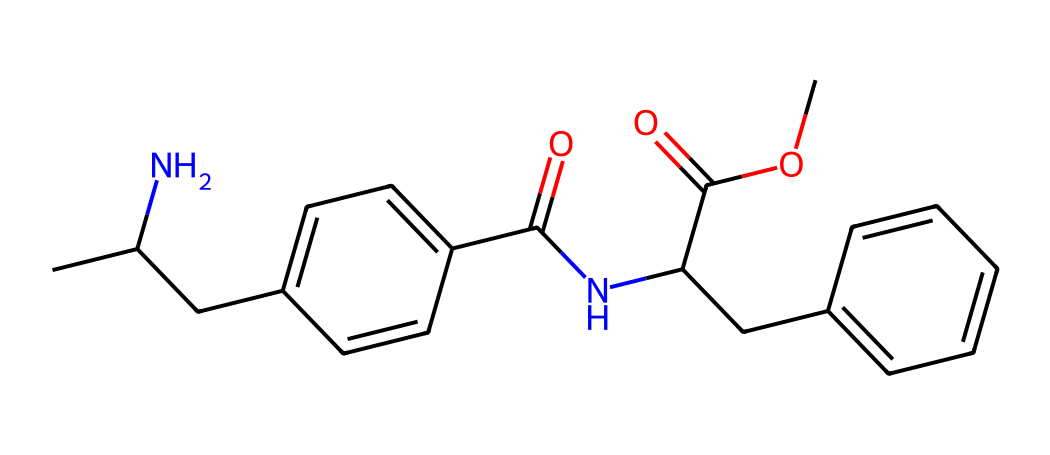What is the main functional group present in this molecule? The molecule contains an amide functional group, which is deduced from the nitrogen atom bonded to the carbonyl (C=O) group. The presence of the carbonyl adjacent to a nitrogen confirms it as an amide.
Answer: amide How many aromatic rings are present in this structure? By examining the structure, we can identify two distinct benzene rings (aromatic rings) based on the presence of alternating double bonds and the specific connectivity of carbon atoms.
Answer: two What is the total number of carbon atoms in this molecule? Counting the carbon atoms in the SMILES representation, we find that there are 19 carbon atoms present in the molecule. This includes carbons from both the aromatic rings and additional carbons in the aliphatic chain.
Answer: 19 Which part of this molecule contributes to its sweetness? The sweetness of aspartame is primarily attributed to the phenylalanine and aspartic acid residues within the structure. These residues mimic the structure of natural sugars.
Answer: phenylalanine and aspartic acid Is this molecule likely to have a bitter aftertaste? Due to the structure of this artificial sweetener, particularly the presence of an amide group and an aromatic system, it is possible that it may present a slight bitter aftertaste, similar to some other artificial sweeteners.
Answer: possible 